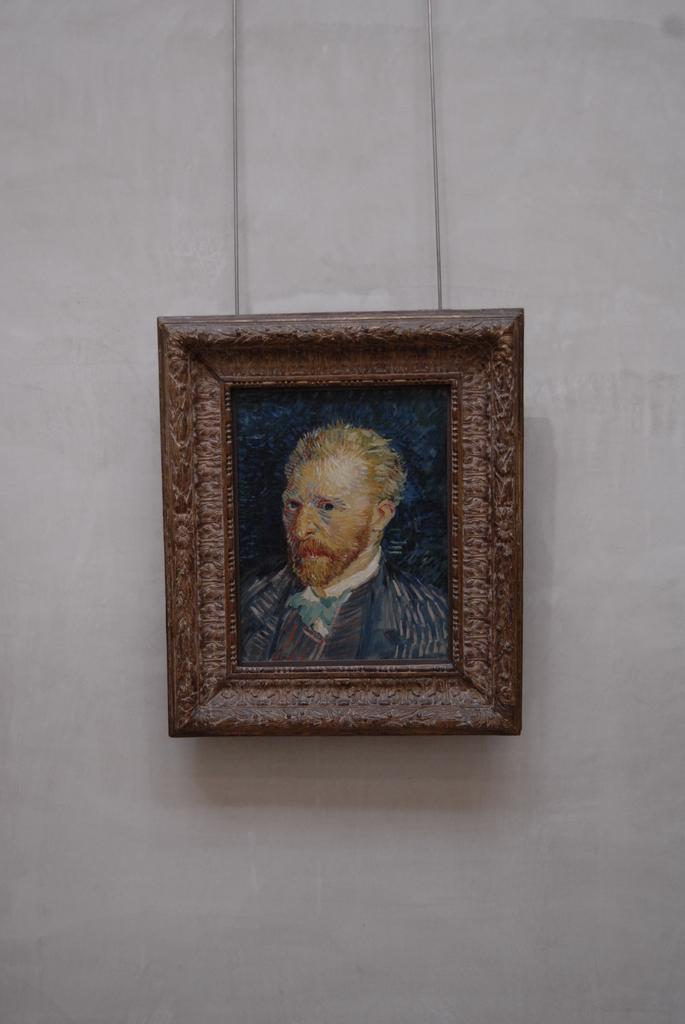What object can be seen in the image that typically holds a photograph? There is a photo frame in the image. Where is the photo frame located? The photo frame is on a wall. What is depicted in the photo frame? There is a painting of a person in the photo frame. How many cars are parked in front of the wall with the photo frame? There is no information about cars or parking in the image, so it cannot be determined. 